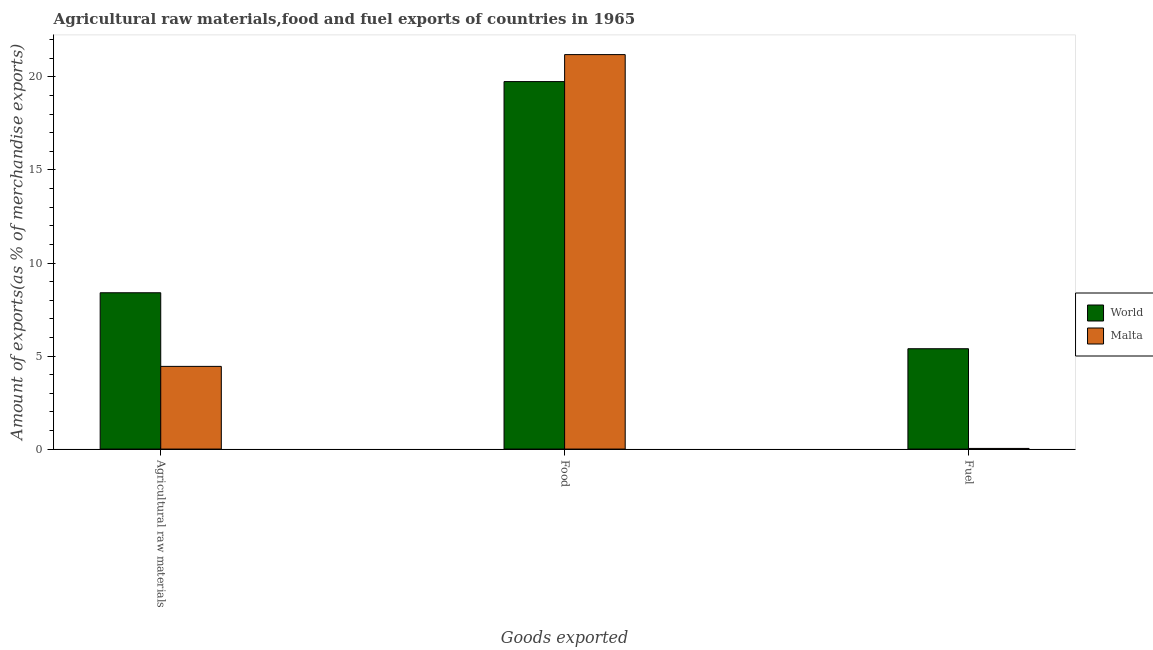Are the number of bars on each tick of the X-axis equal?
Provide a short and direct response. Yes. How many bars are there on the 1st tick from the right?
Give a very brief answer. 2. What is the label of the 1st group of bars from the left?
Keep it short and to the point. Agricultural raw materials. What is the percentage of food exports in World?
Your answer should be compact. 19.75. Across all countries, what is the maximum percentage of food exports?
Make the answer very short. 21.2. Across all countries, what is the minimum percentage of raw materials exports?
Provide a short and direct response. 4.44. In which country was the percentage of food exports maximum?
Your answer should be very brief. Malta. In which country was the percentage of fuel exports minimum?
Keep it short and to the point. Malta. What is the total percentage of raw materials exports in the graph?
Your response must be concise. 12.84. What is the difference between the percentage of fuel exports in Malta and that in World?
Your response must be concise. -5.36. What is the difference between the percentage of raw materials exports in World and the percentage of fuel exports in Malta?
Keep it short and to the point. 8.37. What is the average percentage of fuel exports per country?
Give a very brief answer. 2.71. What is the difference between the percentage of food exports and percentage of fuel exports in Malta?
Ensure brevity in your answer.  21.17. What is the ratio of the percentage of fuel exports in Malta to that in World?
Your answer should be compact. 0.01. Is the percentage of fuel exports in Malta less than that in World?
Keep it short and to the point. Yes. What is the difference between the highest and the second highest percentage of fuel exports?
Make the answer very short. 5.36. What is the difference between the highest and the lowest percentage of raw materials exports?
Give a very brief answer. 3.96. What does the 2nd bar from the left in Fuel represents?
Keep it short and to the point. Malta. What does the 1st bar from the right in Agricultural raw materials represents?
Provide a succinct answer. Malta. How many bars are there?
Provide a short and direct response. 6. Are all the bars in the graph horizontal?
Give a very brief answer. No. Are the values on the major ticks of Y-axis written in scientific E-notation?
Provide a short and direct response. No. Does the graph contain grids?
Make the answer very short. No. How many legend labels are there?
Ensure brevity in your answer.  2. What is the title of the graph?
Ensure brevity in your answer.  Agricultural raw materials,food and fuel exports of countries in 1965. Does "Sierra Leone" appear as one of the legend labels in the graph?
Provide a short and direct response. No. What is the label or title of the X-axis?
Offer a terse response. Goods exported. What is the label or title of the Y-axis?
Keep it short and to the point. Amount of exports(as % of merchandise exports). What is the Amount of exports(as % of merchandise exports) of World in Agricultural raw materials?
Offer a terse response. 8.4. What is the Amount of exports(as % of merchandise exports) of Malta in Agricultural raw materials?
Your answer should be very brief. 4.44. What is the Amount of exports(as % of merchandise exports) in World in Food?
Offer a very short reply. 19.75. What is the Amount of exports(as % of merchandise exports) of Malta in Food?
Your response must be concise. 21.2. What is the Amount of exports(as % of merchandise exports) of World in Fuel?
Your answer should be compact. 5.39. What is the Amount of exports(as % of merchandise exports) of Malta in Fuel?
Your answer should be compact. 0.04. Across all Goods exported, what is the maximum Amount of exports(as % of merchandise exports) in World?
Make the answer very short. 19.75. Across all Goods exported, what is the maximum Amount of exports(as % of merchandise exports) of Malta?
Provide a short and direct response. 21.2. Across all Goods exported, what is the minimum Amount of exports(as % of merchandise exports) in World?
Your answer should be compact. 5.39. Across all Goods exported, what is the minimum Amount of exports(as % of merchandise exports) in Malta?
Your answer should be very brief. 0.04. What is the total Amount of exports(as % of merchandise exports) of World in the graph?
Provide a succinct answer. 33.54. What is the total Amount of exports(as % of merchandise exports) in Malta in the graph?
Provide a short and direct response. 25.68. What is the difference between the Amount of exports(as % of merchandise exports) in World in Agricultural raw materials and that in Food?
Provide a short and direct response. -11.35. What is the difference between the Amount of exports(as % of merchandise exports) of Malta in Agricultural raw materials and that in Food?
Make the answer very short. -16.76. What is the difference between the Amount of exports(as % of merchandise exports) in World in Agricultural raw materials and that in Fuel?
Ensure brevity in your answer.  3.01. What is the difference between the Amount of exports(as % of merchandise exports) in Malta in Agricultural raw materials and that in Fuel?
Your answer should be compact. 4.41. What is the difference between the Amount of exports(as % of merchandise exports) in World in Food and that in Fuel?
Your answer should be compact. 14.36. What is the difference between the Amount of exports(as % of merchandise exports) of Malta in Food and that in Fuel?
Ensure brevity in your answer.  21.17. What is the difference between the Amount of exports(as % of merchandise exports) in World in Agricultural raw materials and the Amount of exports(as % of merchandise exports) in Malta in Food?
Make the answer very short. -12.8. What is the difference between the Amount of exports(as % of merchandise exports) of World in Agricultural raw materials and the Amount of exports(as % of merchandise exports) of Malta in Fuel?
Your response must be concise. 8.37. What is the difference between the Amount of exports(as % of merchandise exports) of World in Food and the Amount of exports(as % of merchandise exports) of Malta in Fuel?
Make the answer very short. 19.72. What is the average Amount of exports(as % of merchandise exports) of World per Goods exported?
Offer a terse response. 11.18. What is the average Amount of exports(as % of merchandise exports) in Malta per Goods exported?
Give a very brief answer. 8.56. What is the difference between the Amount of exports(as % of merchandise exports) in World and Amount of exports(as % of merchandise exports) in Malta in Agricultural raw materials?
Offer a terse response. 3.96. What is the difference between the Amount of exports(as % of merchandise exports) in World and Amount of exports(as % of merchandise exports) in Malta in Food?
Make the answer very short. -1.45. What is the difference between the Amount of exports(as % of merchandise exports) in World and Amount of exports(as % of merchandise exports) in Malta in Fuel?
Make the answer very short. 5.36. What is the ratio of the Amount of exports(as % of merchandise exports) in World in Agricultural raw materials to that in Food?
Provide a short and direct response. 0.43. What is the ratio of the Amount of exports(as % of merchandise exports) of Malta in Agricultural raw materials to that in Food?
Keep it short and to the point. 0.21. What is the ratio of the Amount of exports(as % of merchandise exports) of World in Agricultural raw materials to that in Fuel?
Keep it short and to the point. 1.56. What is the ratio of the Amount of exports(as % of merchandise exports) of Malta in Agricultural raw materials to that in Fuel?
Offer a terse response. 126.96. What is the ratio of the Amount of exports(as % of merchandise exports) of World in Food to that in Fuel?
Offer a terse response. 3.66. What is the ratio of the Amount of exports(as % of merchandise exports) in Malta in Food to that in Fuel?
Ensure brevity in your answer.  605.67. What is the difference between the highest and the second highest Amount of exports(as % of merchandise exports) of World?
Your answer should be compact. 11.35. What is the difference between the highest and the second highest Amount of exports(as % of merchandise exports) of Malta?
Provide a short and direct response. 16.76. What is the difference between the highest and the lowest Amount of exports(as % of merchandise exports) of World?
Your response must be concise. 14.36. What is the difference between the highest and the lowest Amount of exports(as % of merchandise exports) of Malta?
Offer a terse response. 21.17. 